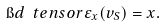Convert formula to latex. <formula><loc_0><loc_0><loc_500><loc_500>\i d \ t e n s o r \varepsilon _ { x } ( v _ { S } ) = x .</formula> 